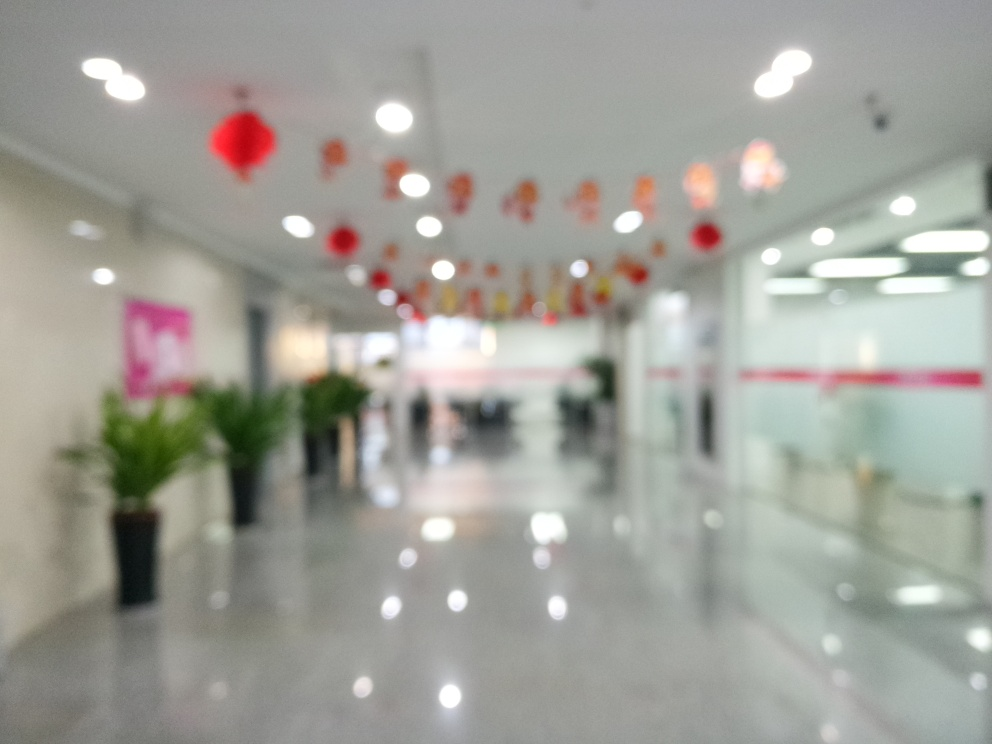Is the image highly detailed? Based on the visible content, the image is not highly detailed as it is out of focus, which obscures the fine elements and textures that would typically characterize a detailed photograph. 